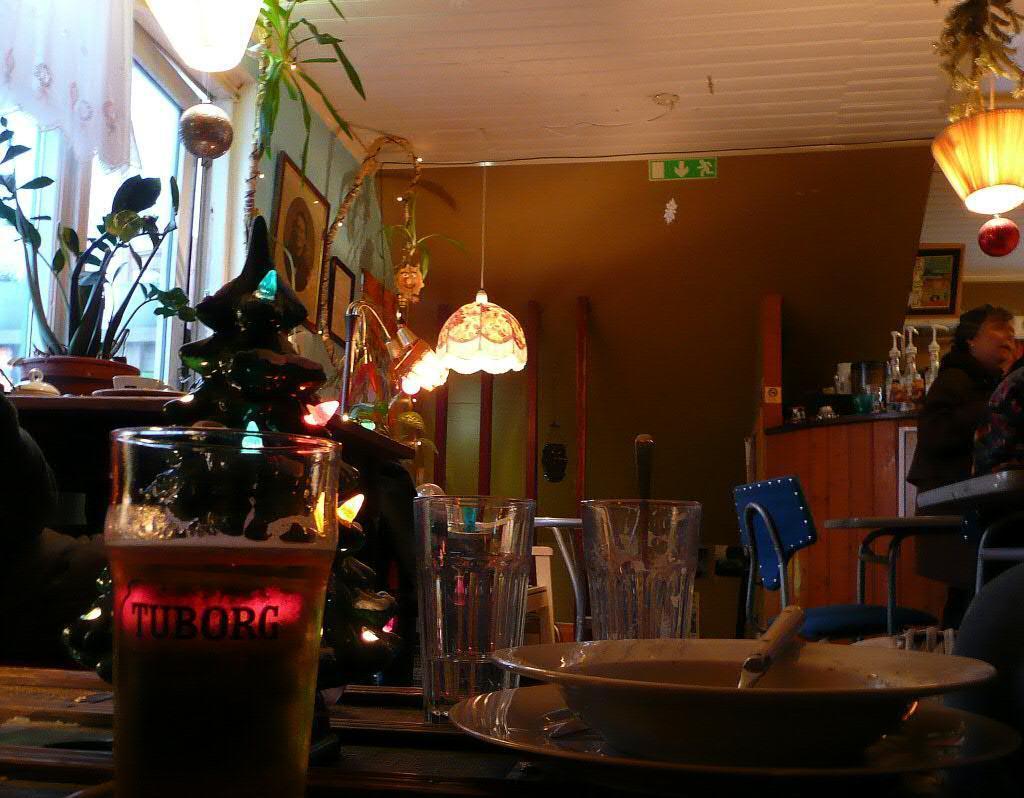Describe this image in one or two sentences. Here we can see a glass and bowl and some objects on the table, and at side persons are sitting on the chair, and at above here are the lights, and here is the wall and photo frames on it, and here are the flower pots. 